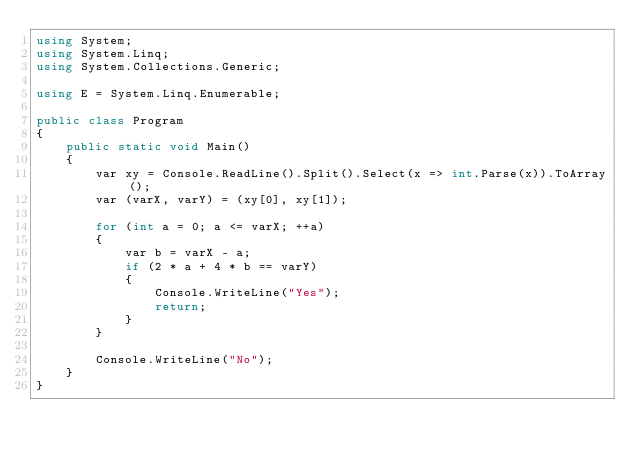Convert code to text. <code><loc_0><loc_0><loc_500><loc_500><_C#_>using System;
using System.Linq;
using System.Collections.Generic;

using E = System.Linq.Enumerable;

public class Program
{
    public static void Main()
    {
        var xy = Console.ReadLine().Split().Select(x => int.Parse(x)).ToArray();
        var (varX, varY) = (xy[0], xy[1]);

        for (int a = 0; a <= varX; ++a)
        {
            var b = varX - a;
            if (2 * a + 4 * b == varY)
            {
                Console.WriteLine("Yes");
                return;
            }
        }

        Console.WriteLine("No");
    }
}
</code> 